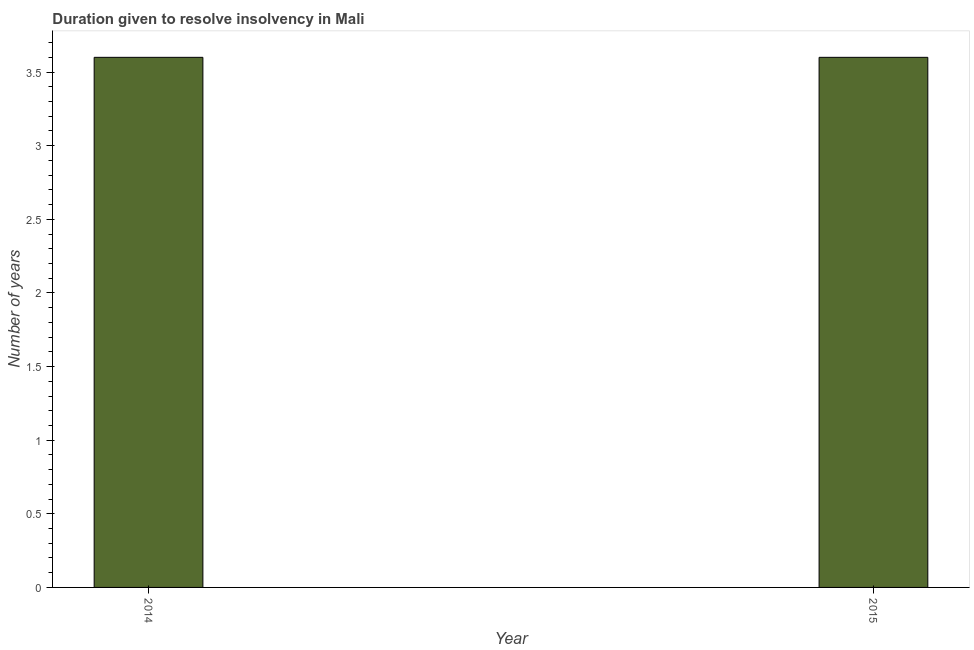Does the graph contain grids?
Your answer should be compact. No. What is the title of the graph?
Make the answer very short. Duration given to resolve insolvency in Mali. What is the label or title of the Y-axis?
Your response must be concise. Number of years. In which year was the number of years to resolve insolvency maximum?
Offer a terse response. 2014. In which year was the number of years to resolve insolvency minimum?
Your answer should be compact. 2014. What is the average number of years to resolve insolvency per year?
Keep it short and to the point. 3.6. In how many years, is the number of years to resolve insolvency greater than 3.5 ?
Your response must be concise. 2. Do a majority of the years between 2015 and 2014 (inclusive) have number of years to resolve insolvency greater than 2.1 ?
Your answer should be compact. No. What is the ratio of the number of years to resolve insolvency in 2014 to that in 2015?
Offer a very short reply. 1. What is the difference between two consecutive major ticks on the Y-axis?
Your answer should be compact. 0.5. Are the values on the major ticks of Y-axis written in scientific E-notation?
Your answer should be very brief. No. What is the difference between the Number of years in 2014 and 2015?
Keep it short and to the point. 0. What is the ratio of the Number of years in 2014 to that in 2015?
Your response must be concise. 1. 